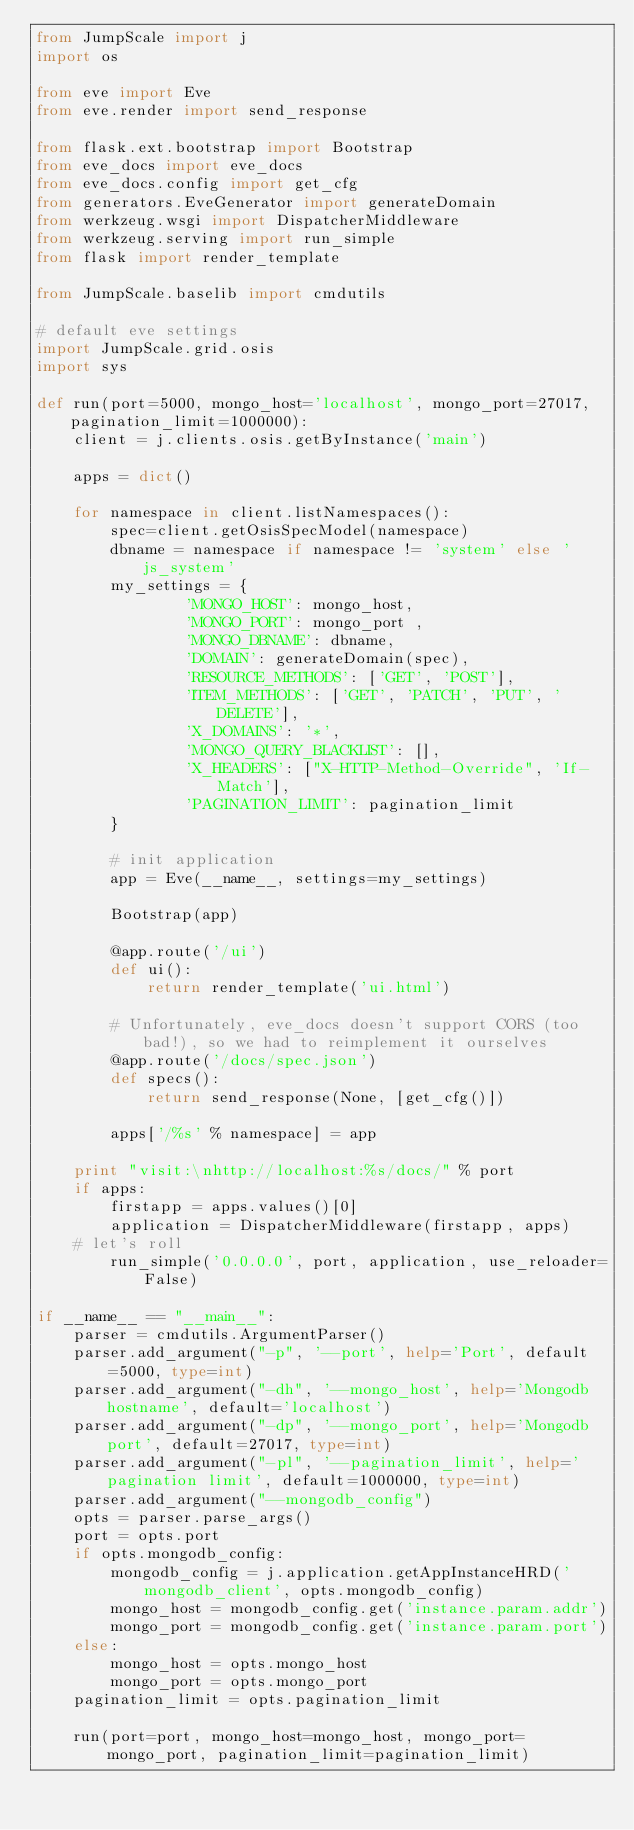<code> <loc_0><loc_0><loc_500><loc_500><_Python_>from JumpScale import j
import os

from eve import Eve
from eve.render import send_response

from flask.ext.bootstrap import Bootstrap
from eve_docs import eve_docs
from eve_docs.config import get_cfg
from generators.EveGenerator import generateDomain
from werkzeug.wsgi import DispatcherMiddleware
from werkzeug.serving import run_simple
from flask import render_template

from JumpScale.baselib import cmdutils

# default eve settings
import JumpScale.grid.osis
import sys

def run(port=5000, mongo_host='localhost', mongo_port=27017, pagination_limit=1000000):
    client = j.clients.osis.getByInstance('main')

    apps = dict()
    
    for namespace in client.listNamespaces():
        spec=client.getOsisSpecModel(namespace)
        dbname = namespace if namespace != 'system' else 'js_system'
        my_settings = {
                'MONGO_HOST': mongo_host,
                'MONGO_PORT': mongo_port ,
                'MONGO_DBNAME': dbname,
                'DOMAIN': generateDomain(spec),
                'RESOURCE_METHODS': ['GET', 'POST'],
                'ITEM_METHODS': ['GET', 'PATCH', 'PUT', 'DELETE'],
                'X_DOMAINS': '*',
                'MONGO_QUERY_BLACKLIST': [],
                'X_HEADERS': ["X-HTTP-Method-Override", 'If-Match'],
                'PAGINATION_LIMIT': pagination_limit
        }
    
        # init application
        app = Eve(__name__, settings=my_settings)
    
        Bootstrap(app)
    
        @app.route('/ui')
        def ui():
            return render_template('ui.html')
    
        # Unfortunately, eve_docs doesn't support CORS (too bad!), so we had to reimplement it ourselves
        @app.route('/docs/spec.json')
        def specs():
            return send_response(None, [get_cfg()])
    
        apps['/%s' % namespace] = app 
    
    print "visit:\nhttp://localhost:%s/docs/" % port
    if apps:
        firstapp = apps.values()[0]
        application = DispatcherMiddleware(firstapp, apps)
    # let's roll
        run_simple('0.0.0.0', port, application, use_reloader=False)

if __name__ == "__main__":
    parser = cmdutils.ArgumentParser()
    parser.add_argument("-p", '--port', help='Port', default=5000, type=int)
    parser.add_argument("-dh", '--mongo_host', help='Mongodb hostname', default='localhost')
    parser.add_argument("-dp", '--mongo_port', help='Mongodb port', default=27017, type=int)
    parser.add_argument("-pl", '--pagination_limit', help='pagination limit', default=1000000, type=int)
    parser.add_argument("--mongodb_config")
    opts = parser.parse_args()
    port = opts.port
    if opts.mongodb_config:
        mongodb_config = j.application.getAppInstanceHRD('mongodb_client', opts.mongodb_config)
        mongo_host = mongodb_config.get('instance.param.addr')
        mongo_port = mongodb_config.get('instance.param.port')
    else:
        mongo_host = opts.mongo_host
        mongo_port = opts.mongo_port
    pagination_limit = opts.pagination_limit

    run(port=port, mongo_host=mongo_host, mongo_port=mongo_port, pagination_limit=pagination_limit)
</code> 